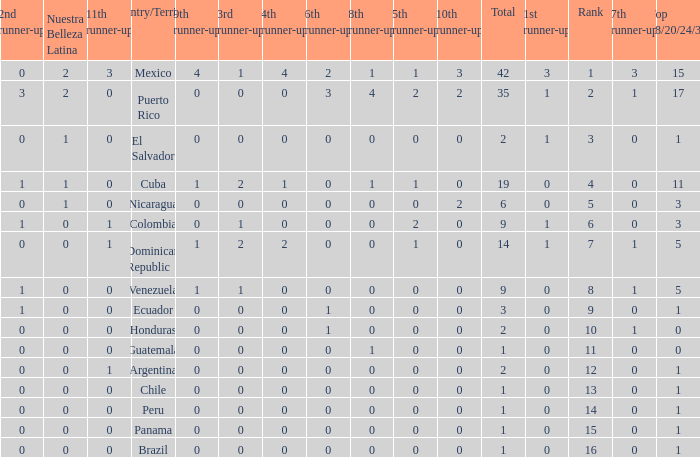What is the total number of 3rd runners-up of the country ranked lower than 12 with a 10th runner-up of 0, an 8th runner-up less than 1, and a 7th runner-up of 0? 4.0. 